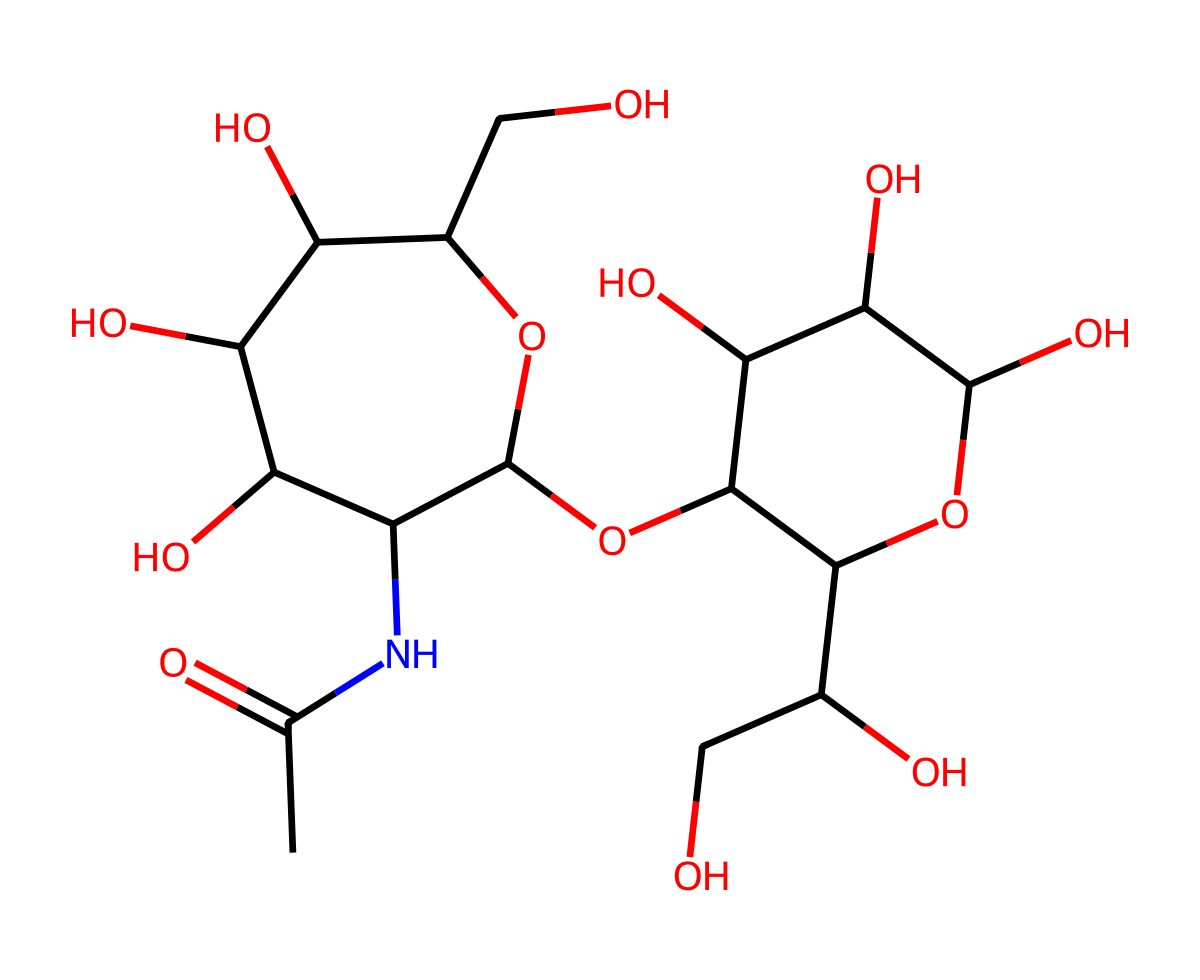What is the main functional group present in hyaluronic acid? The structural formula includes an amide functional group, indicated by the -NC(=O) section in the molecule. This shows that it has a carbonyl group (C=O) attached to a nitrogen atom.
Answer: amide How many carbon atoms are present in hyaluronic acid? Counting the carbon atoms from the SMILES representation reveals a total of 16 carbon atoms in the molecule.
Answer: 16 What type of polymer is hyaluronic acid classified as? Hyaluronic acid is a glycosaminoglycan, which is a type of polysaccharide consisting of repeated disaccharide units.
Answer: polysaccharide What is the significance of the hydroxyl (-OH) groups in hyaluronic acid? The hydroxyl groups contribute to the hydrophilicity of hyaluronic acid, allowing it to attract and retain water, which is crucial for its role in skincare.
Answer: hydrophilicity What is the total number of oxygen atoms in hyaluronic acid? By analyzing the chemical structure, we can identify that there are 6 oxygen atoms in the molecule.
Answer: 6 